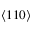<formula> <loc_0><loc_0><loc_500><loc_500>\langle 1 1 0 \rangle</formula> 